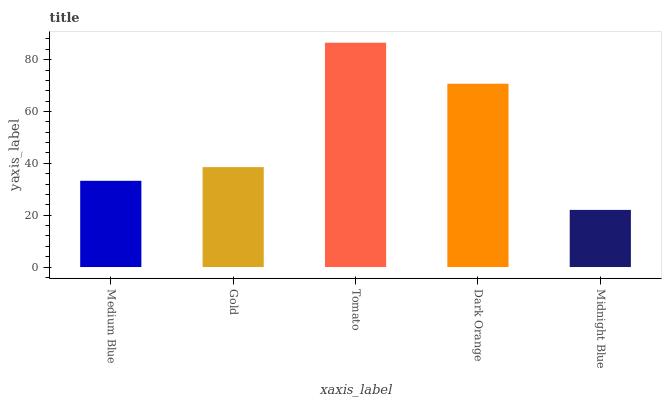Is Midnight Blue the minimum?
Answer yes or no. Yes. Is Tomato the maximum?
Answer yes or no. Yes. Is Gold the minimum?
Answer yes or no. No. Is Gold the maximum?
Answer yes or no. No. Is Gold greater than Medium Blue?
Answer yes or no. Yes. Is Medium Blue less than Gold?
Answer yes or no. Yes. Is Medium Blue greater than Gold?
Answer yes or no. No. Is Gold less than Medium Blue?
Answer yes or no. No. Is Gold the high median?
Answer yes or no. Yes. Is Gold the low median?
Answer yes or no. Yes. Is Medium Blue the high median?
Answer yes or no. No. Is Dark Orange the low median?
Answer yes or no. No. 